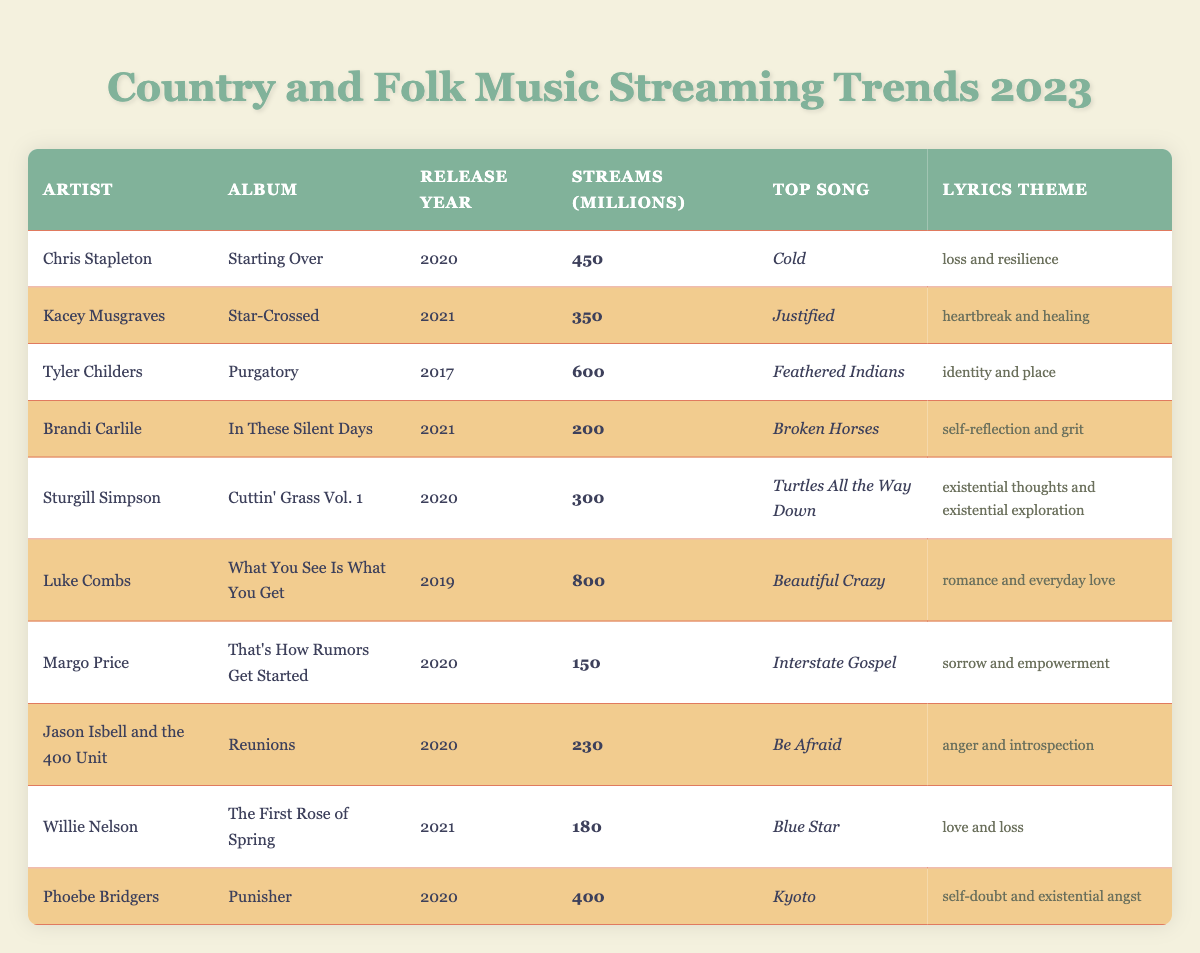What's the top song from Luke Combs' album? The table lists Luke Combs with the album "What You See Is What You Get," and his top song is clearly stated as "Beautiful Crazy."
Answer: Beautiful Crazy Which artist had the most streams in millions? By comparing the "streams (Millions)" column, Luke Combs has the highest number of 800 million streams.
Answer: Luke Combs What is the lyrics theme of Kacey Musgraves' album "Star-Crossed"? The table indicates that Kacey Musgraves' album "Star-Crossed" has a lyrics theme of "heartbreak and healing."
Answer: heartbreak and healing How many streams did Brandi Carlile's album get? The streams for Brandi Carlile as presented in the table is 200 million.
Answer: 200 What is the average number of streams for all artists listed? We sum the streams: (450 + 350 + 600 + 200 + 300 + 800 + 150 + 230 + 180 + 400) = 2860. There are 10 artists, so the average is 2860 / 10 = 286.
Answer: 286 Is the top song of Tyler Childers' album "Purgatory" "Feathered Indians"? Yes, according to the table, the top song for Tyler Childers' album "Purgatory" is indeed "Feathered Indians."
Answer: Yes Which album released in 2021 had the lowest streams? Comparing the streams of albums released in 2021, Kacey Musgraves with "Star-Crossed" at 350 million has higher streams than Brandi Carlile’s "In These Silent Days" which has 200 million. Therefore, the lowest is by Brandi Carlile.
Answer: In These Silent Days How many artists have a lyrics theme related to love? By examining the "lyrics theme" column, the themes related to love are found in Luke Combs' "romance and everyday love" and Willie Nelson's "love and loss" — two artists.
Answer: 2 What is the difference in streams between Tyler Childers and Chris Stapleton? Tyler Childers has 600 million streams and Chris Stapleton has 450 million streams. The difference is 600 - 450 = 150 million.
Answer: 150 Which artist's work focuses on self-reflection? Brandi Carlile's album "In These Silent Days" focuses on "self-reflection and grit," making her the artist with this theme.
Answer: Brandi Carlile 